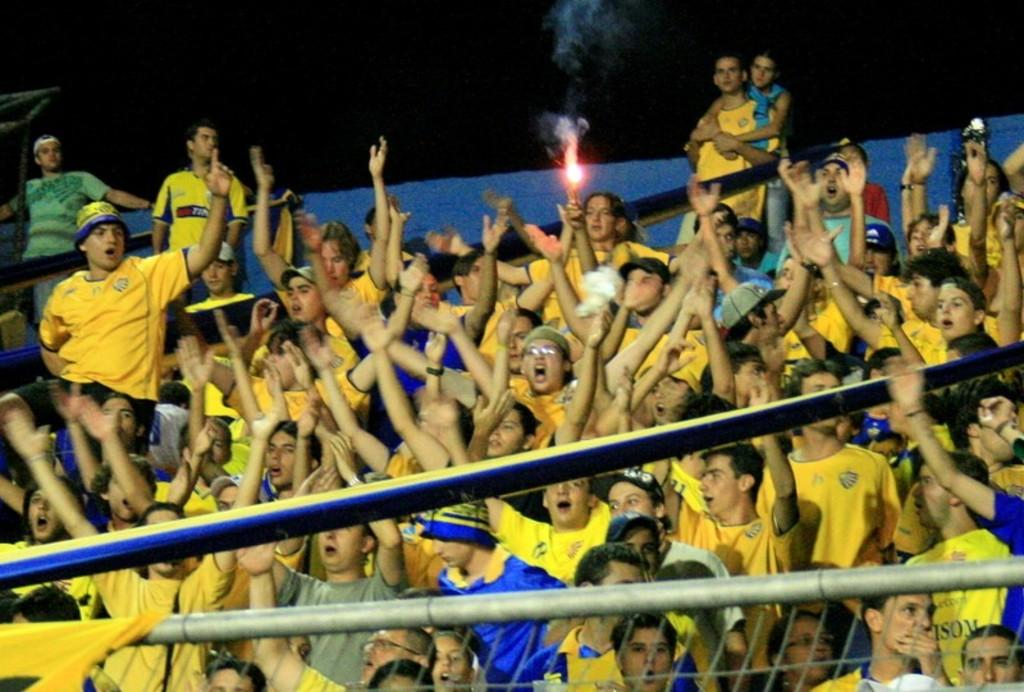What are the people in the image doing? The people in the image are sitting. What is the person in the center holding? The person sitting in the center is holding a lamp. What can be seen at the bottom of the image? There are rods at the bottom of the image. What type of lawyer is sitting next to the person holding the lamp? There is no lawyer present in the image; it only shows people sitting and a person holding a lamp. 